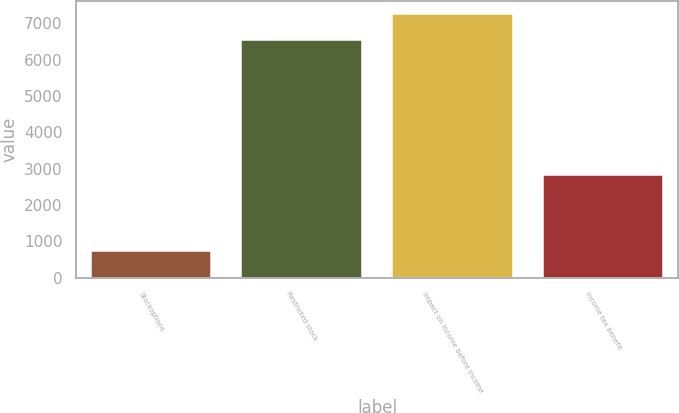Convert chart. <chart><loc_0><loc_0><loc_500><loc_500><bar_chart><fcel>Stockoptions<fcel>Restricted stock<fcel>Impact on income before income<fcel>Income tax benefit<nl><fcel>720<fcel>6541<fcel>7261<fcel>2827<nl></chart> 